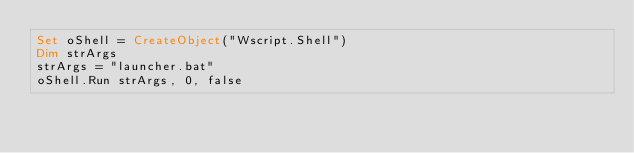<code> <loc_0><loc_0><loc_500><loc_500><_VisualBasic_>Set oShell = CreateObject("Wscript.Shell")
Dim strArgs
strArgs = "launcher.bat"
oShell.Run strArgs, 0, false</code> 